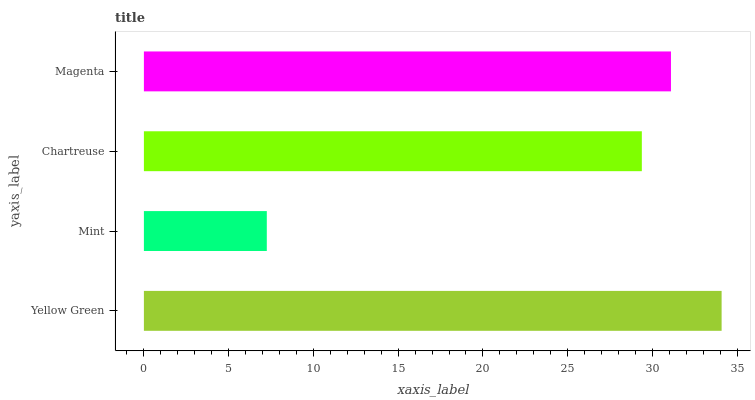Is Mint the minimum?
Answer yes or no. Yes. Is Yellow Green the maximum?
Answer yes or no. Yes. Is Chartreuse the minimum?
Answer yes or no. No. Is Chartreuse the maximum?
Answer yes or no. No. Is Chartreuse greater than Mint?
Answer yes or no. Yes. Is Mint less than Chartreuse?
Answer yes or no. Yes. Is Mint greater than Chartreuse?
Answer yes or no. No. Is Chartreuse less than Mint?
Answer yes or no. No. Is Magenta the high median?
Answer yes or no. Yes. Is Chartreuse the low median?
Answer yes or no. Yes. Is Chartreuse the high median?
Answer yes or no. No. Is Mint the low median?
Answer yes or no. No. 